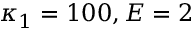Convert formula to latex. <formula><loc_0><loc_0><loc_500><loc_500>\kappa _ { 1 } = 1 0 0 , E = 2</formula> 